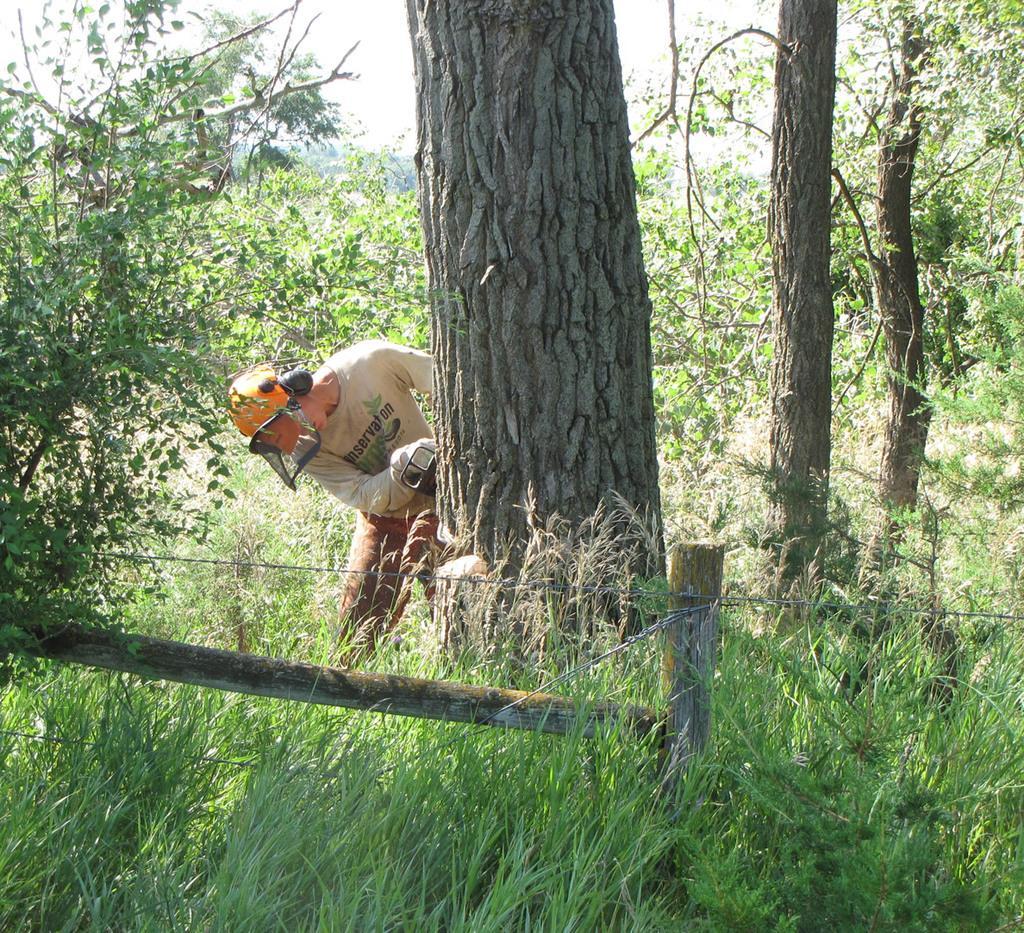Can you describe this image briefly? In this image I can see one person is holding something and wearing helmet. I can see few trees, grass, fencing and sky is in white color. 